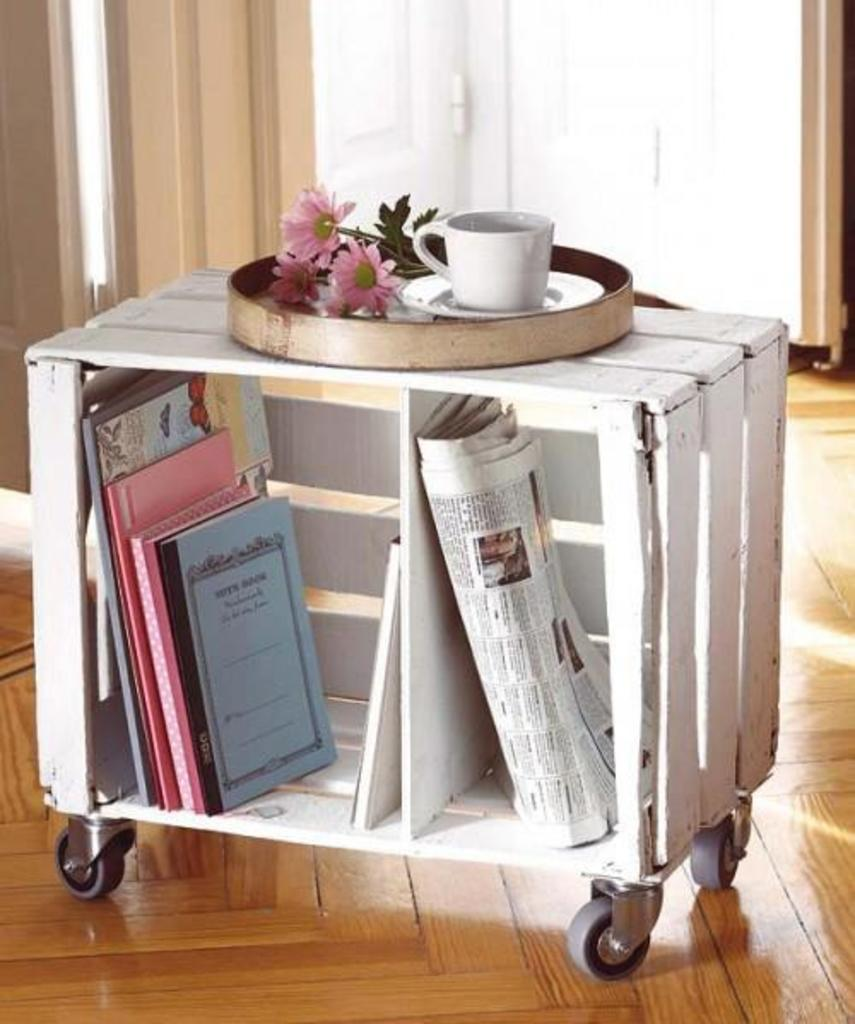What type of furniture is present in the image? There is a table in the image. What items are placed on the table? There are papers, books, a cup, a saucer, and flowers on the table. Can you describe the cup and saucer? The cup and saucer are separate items on the table. What might be used for decoration on the table? The flowers on the table can be used for decoration. What type of throne is present in the image? There is no throne present in the image; it features a table with various items on it. What type of club can be seen in the image? There is no club present in the image; it features a table with various items on it. 